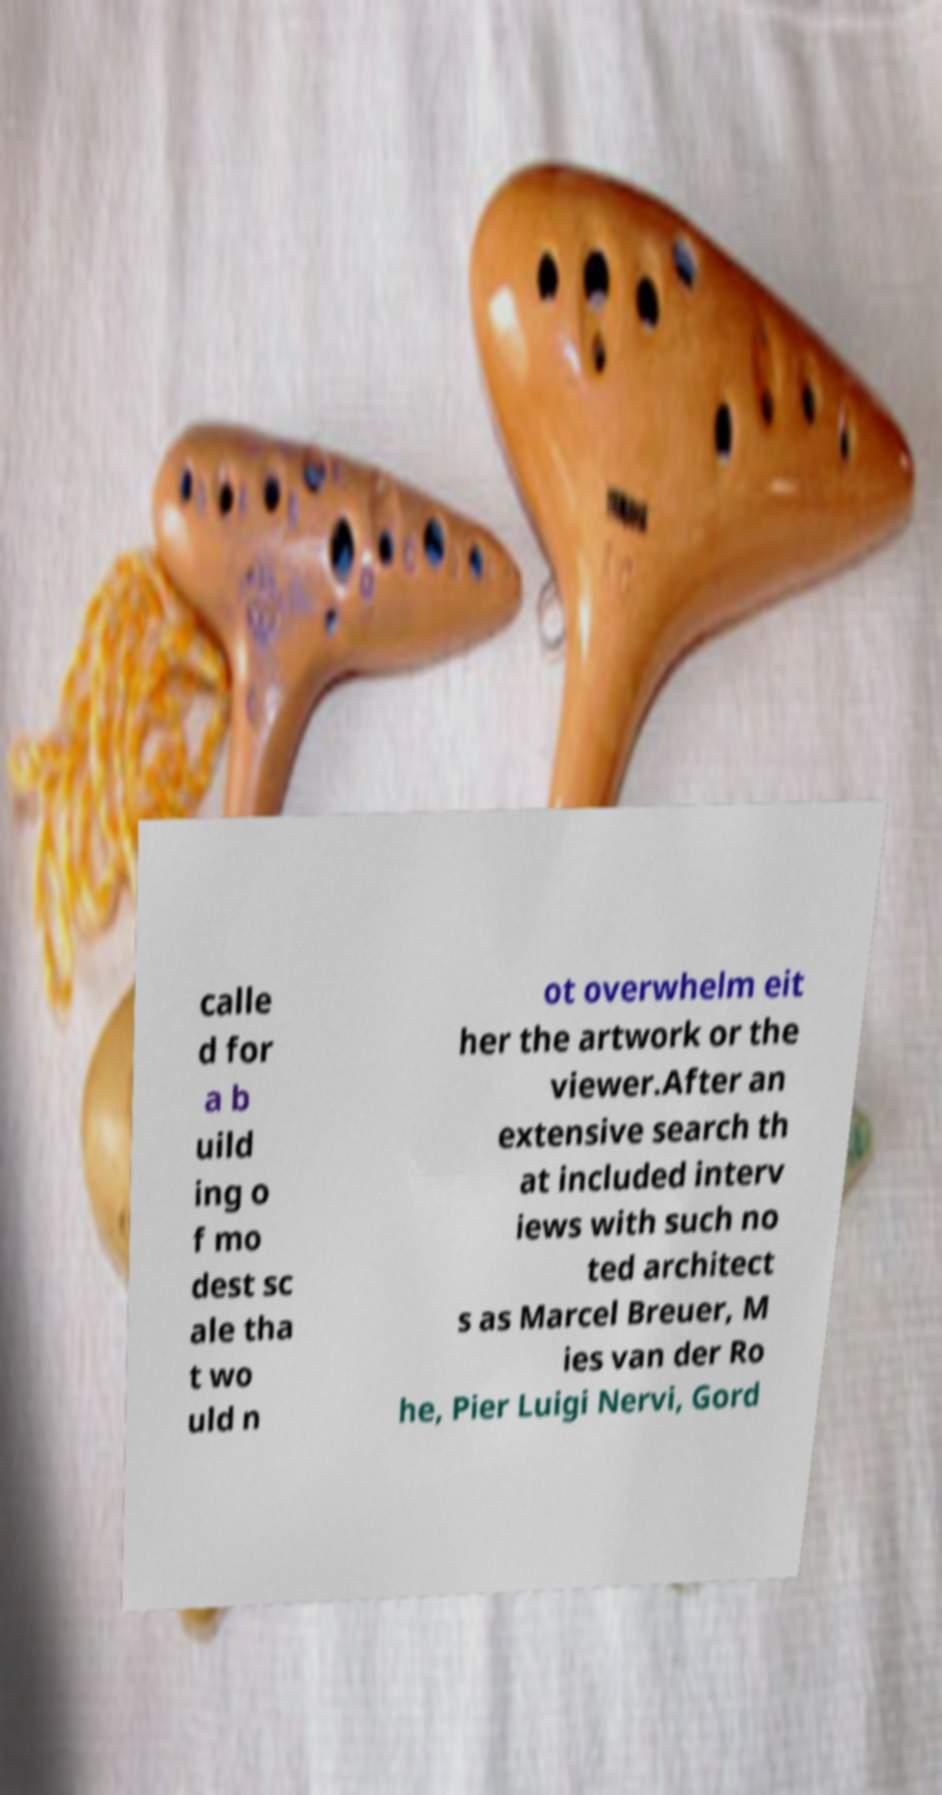Please read and relay the text visible in this image. What does it say? calle d for a b uild ing o f mo dest sc ale tha t wo uld n ot overwhelm eit her the artwork or the viewer.After an extensive search th at included interv iews with such no ted architect s as Marcel Breuer, M ies van der Ro he, Pier Luigi Nervi, Gord 